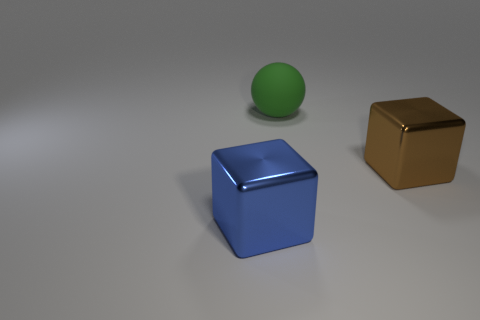Add 1 brown metal blocks. How many objects exist? 4 Subtract all blocks. How many objects are left? 1 Subtract 0 yellow spheres. How many objects are left? 3 Subtract all spheres. Subtract all big matte balls. How many objects are left? 1 Add 3 large brown things. How many large brown things are left? 4 Add 1 yellow spheres. How many yellow spheres exist? 1 